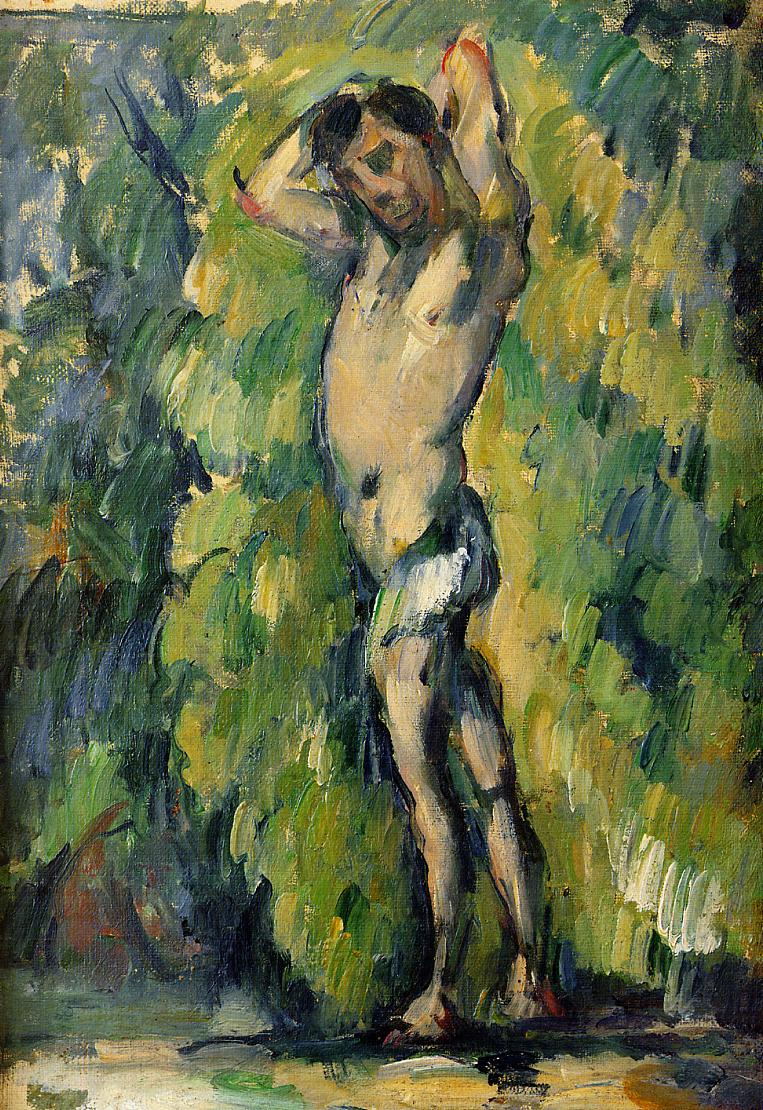How does the style of painting affect the mood of the scene? The impressionistic approach, with its loose brushwork and vibrant interplay of colors, enhances the ephemeral quality of the scene. It seems to capture a fleeting moment in nature, and this, mixed with the vague outlines of the figure, adds a dreamlike, almost mystical atmosphere to the painting. 